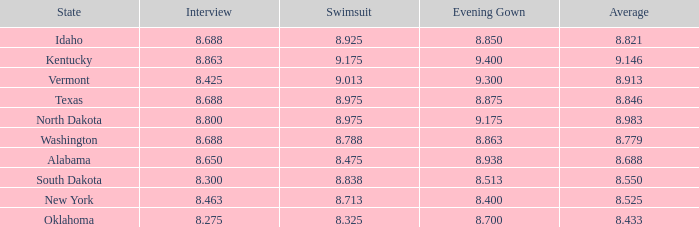What is the lowest average of the contestant with an interview of 8.275 and an evening gown bigger than 8.7? None. 